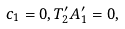Convert formula to latex. <formula><loc_0><loc_0><loc_500><loc_500>c _ { 1 } = 0 , T ^ { \prime } _ { 2 } A ^ { \prime } _ { 1 } = 0 ,</formula> 